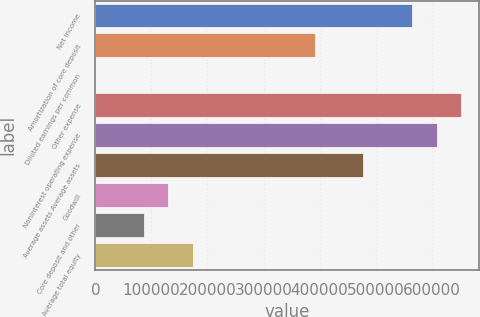Convert chart to OTSL. <chart><loc_0><loc_0><loc_500><loc_500><bar_chart><fcel>Net income<fcel>Amortization of core deposit<fcel>Diluted earnings per common<fcel>Other expense<fcel>Noninterest operating expense<fcel>Average assets Average assets<fcel>Goodwill<fcel>Core deposit and other<fcel>Average total equity<nl><fcel>565192<fcel>391287<fcel>0.82<fcel>652144<fcel>608668<fcel>478239<fcel>130429<fcel>86953.3<fcel>173906<nl></chart> 